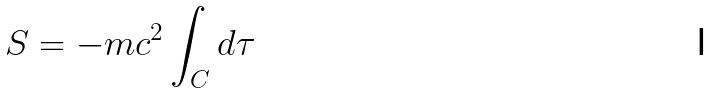<formula> <loc_0><loc_0><loc_500><loc_500>S = - m c ^ { 2 } \int _ { C } d \tau</formula> 